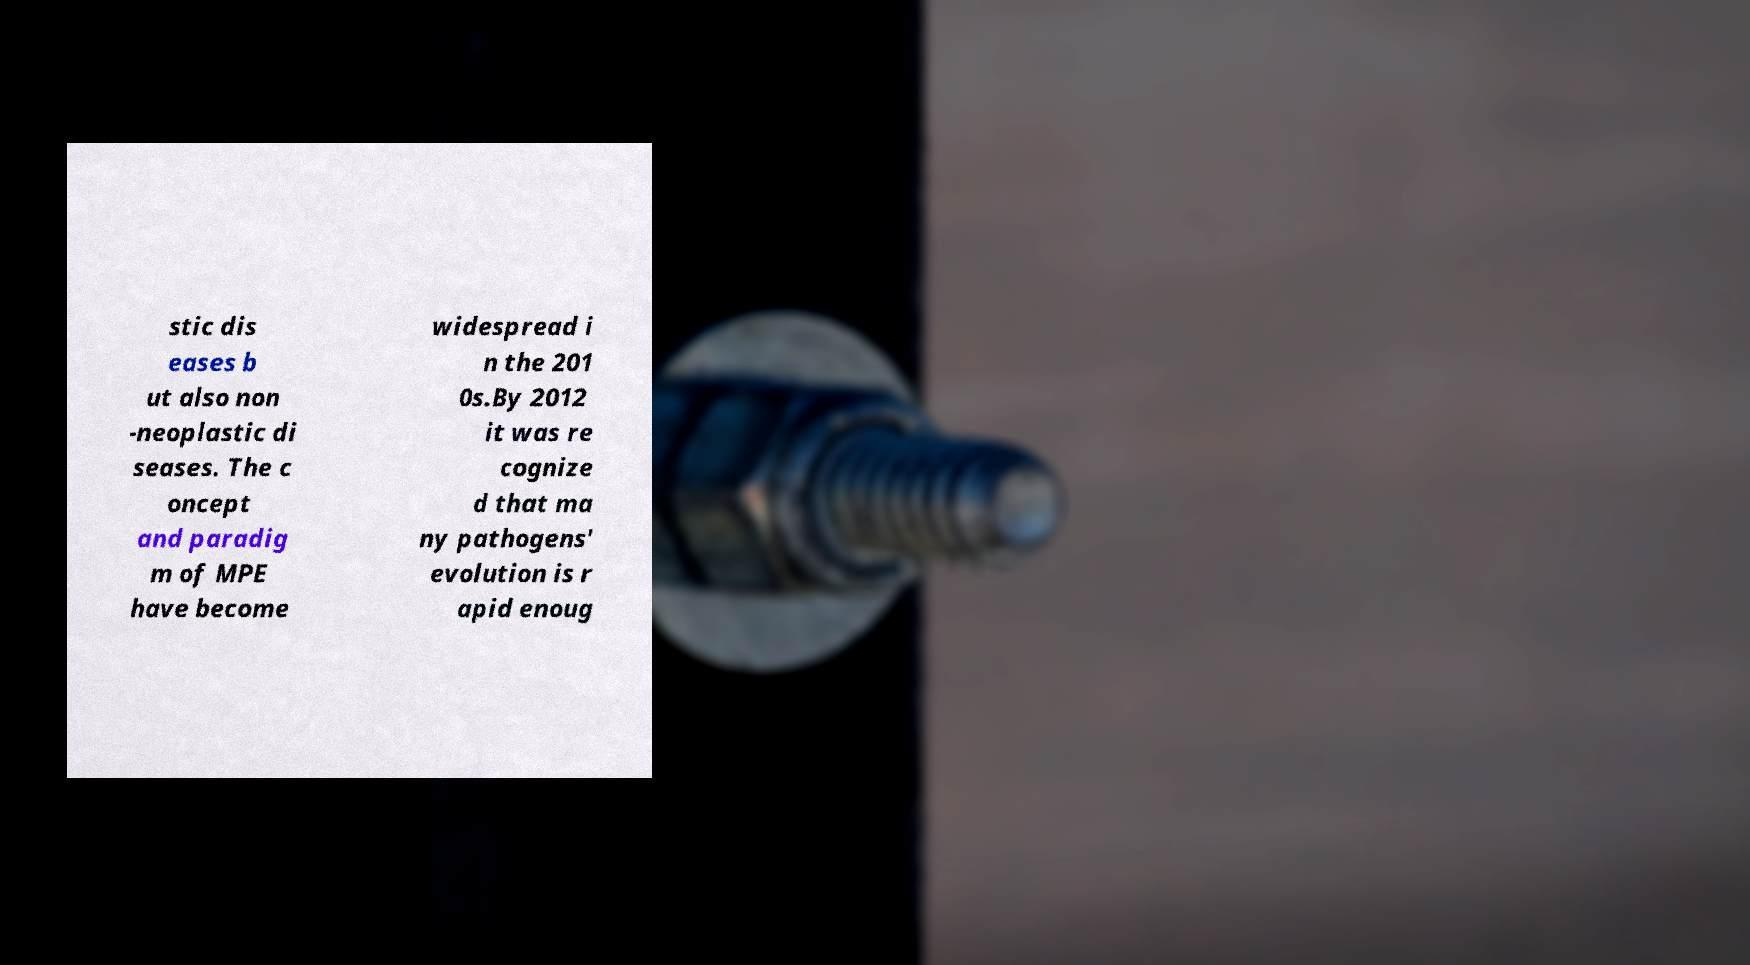Can you accurately transcribe the text from the provided image for me? stic dis eases b ut also non -neoplastic di seases. The c oncept and paradig m of MPE have become widespread i n the 201 0s.By 2012 it was re cognize d that ma ny pathogens' evolution is r apid enoug 